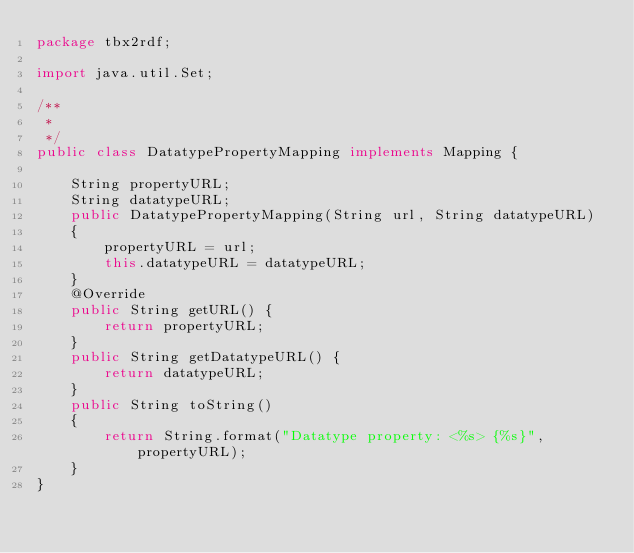<code> <loc_0><loc_0><loc_500><loc_500><_Java_>package tbx2rdf;

import java.util.Set;

/**
 * 
 */
public class DatatypePropertyMapping implements Mapping {

	String propertyURL;
	String datatypeURL;
	public DatatypePropertyMapping(String url, String datatypeURL)
	{
		propertyURL = url;
		this.datatypeURL = datatypeURL;
	}
	@Override
	public String getURL() {
		return propertyURL;
	}
	public String getDatatypeURL() { 
		return datatypeURL;
	}
	public String toString()
	{
		return String.format("Datatype property: <%s> {%s}",propertyURL);
	}
}
</code> 